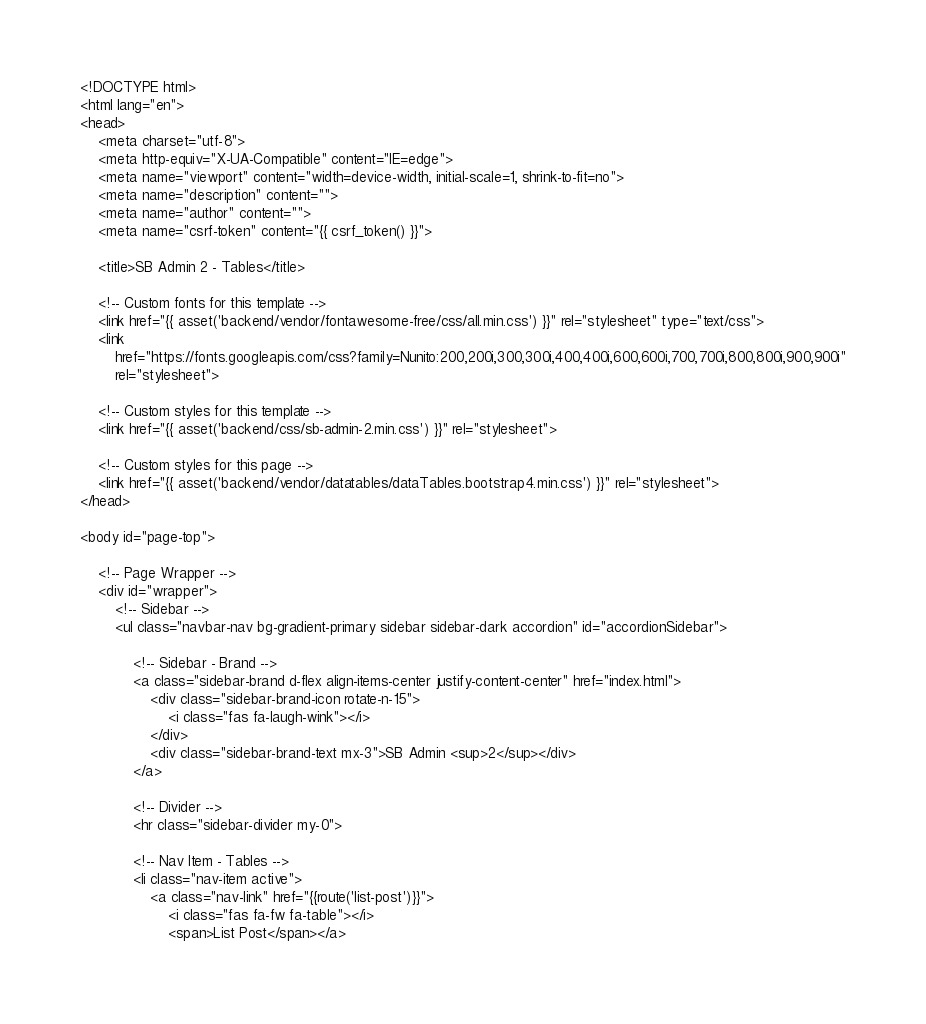<code> <loc_0><loc_0><loc_500><loc_500><_PHP_><!DOCTYPE html>
<html lang="en">
<head>
    <meta charset="utf-8">
    <meta http-equiv="X-UA-Compatible" content="IE=edge">
    <meta name="viewport" content="width=device-width, initial-scale=1, shrink-to-fit=no">
    <meta name="description" content="">
    <meta name="author" content="">
    <meta name="csrf-token" content="{{ csrf_token() }}">

    <title>SB Admin 2 - Tables</title>

    <!-- Custom fonts for this template -->
    <link href="{{ asset('backend/vendor/fontawesome-free/css/all.min.css') }}" rel="stylesheet" type="text/css">
    <link
        href="https://fonts.googleapis.com/css?family=Nunito:200,200i,300,300i,400,400i,600,600i,700,700i,800,800i,900,900i"
        rel="stylesheet">

    <!-- Custom styles for this template -->
    <link href="{{ asset('backend/css/sb-admin-2.min.css') }}" rel="stylesheet">

    <!-- Custom styles for this page -->
    <link href="{{ asset('backend/vendor/datatables/dataTables.bootstrap4.min.css') }}" rel="stylesheet">
</head>

<body id="page-top">

    <!-- Page Wrapper -->
    <div id="wrapper">
        <!-- Sidebar -->
        <ul class="navbar-nav bg-gradient-primary sidebar sidebar-dark accordion" id="accordionSidebar">

            <!-- Sidebar - Brand -->
            <a class="sidebar-brand d-flex align-items-center justify-content-center" href="index.html">
                <div class="sidebar-brand-icon rotate-n-15">
                    <i class="fas fa-laugh-wink"></i>
                </div>
                <div class="sidebar-brand-text mx-3">SB Admin <sup>2</sup></div>
            </a>

            <!-- Divider -->
            <hr class="sidebar-divider my-0">

            <!-- Nav Item - Tables -->
            <li class="nav-item active">
                <a class="nav-link" href="{{route('list-post')}}">
                    <i class="fas fa-fw fa-table"></i>
                    <span>List Post</span></a></code> 